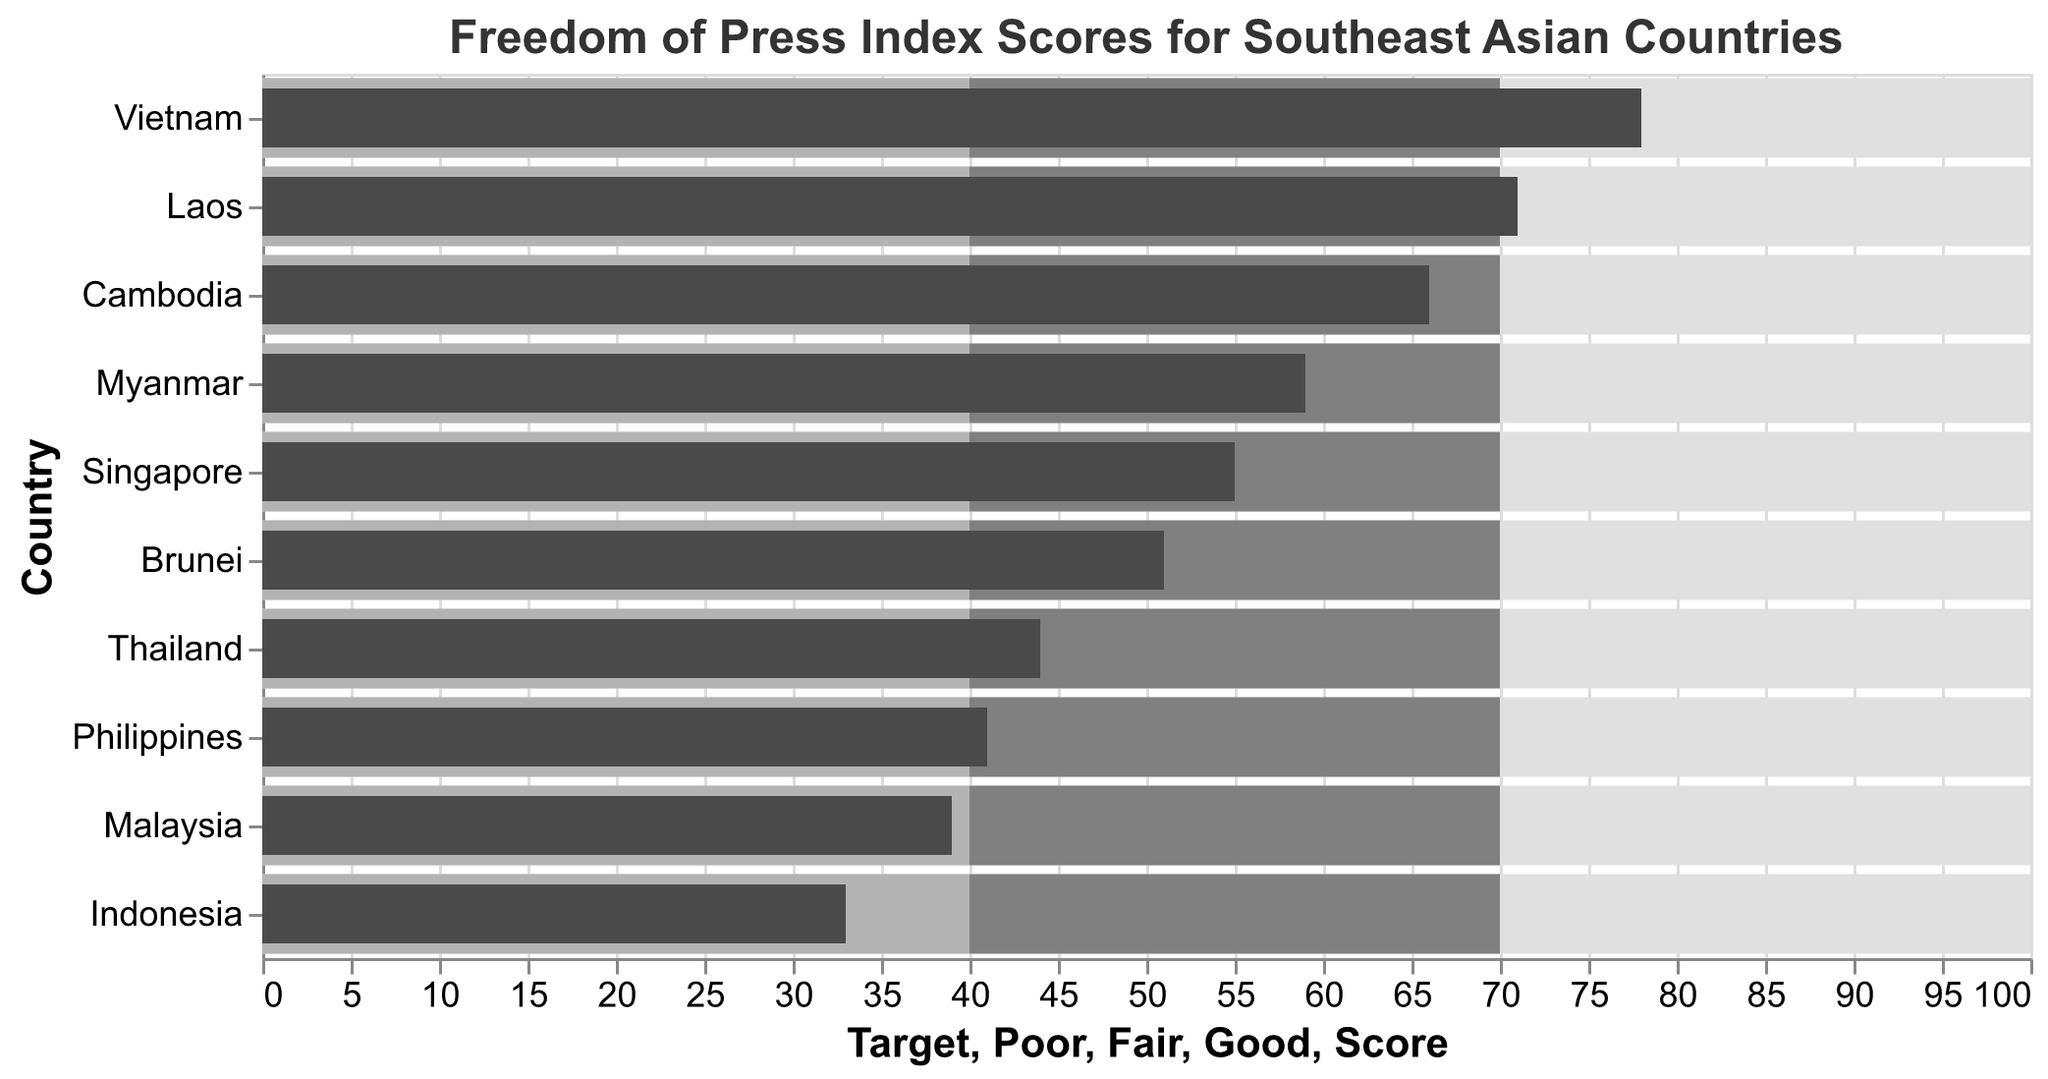What is the score of Vietnam on the Freedom of Press Index? Look for Vietnam in the y-axis and follow along to its score on the x-axis. The score value for Vietnam is 78.
Answer: 78 Which country has the lowest score on the Freedom of Press Index? Compare the scores of all countries. Indonesia has the lowest score at 33.
Answer: Indonesia How many countries have a score below the 'Fair' category threshold? The 'Fair' category threshold is set at 40. Count the number of countries with a score below 40. Indonesia (33), Malaysia (39) are below 40.
Answer: 2 Which countries fall into the 'Good' category for the Freedom of Press Index? The 'Good' category threshold begins at 70. Look for countries with scores above 70. No country has a score within the 'Good' threshold (above 70).
Answer: None How does Brunei's score compare to the average score of all countries? To find Brunei's score is 51. Find the average by summing all scores and dividing by the number of countries: (55 + 78 + 44 + 39 + 33 + 41 + 59 + 66 + 71 + 51) / 10 = 53.7. Brunei's score is 51, which is below the average of 53.7.
Answer: Below average What is the range of scores for these Southeast Asian countries? The range is calculated as the difference between the highest and lowest scores. The highest score is 78 (Vietnam) and the lowest is 33 (Indonesia), so the range is 78 - 33.
Answer: 45 Which country just missed the 'Good' category threshold, having the highest score below 70? Look for the country with the highest score below the 'Good' threshold of 70. Myanmar has a score of 59, which is just below the 'Good' threshold and is the highest score below 70.
Answer: Myanmar 